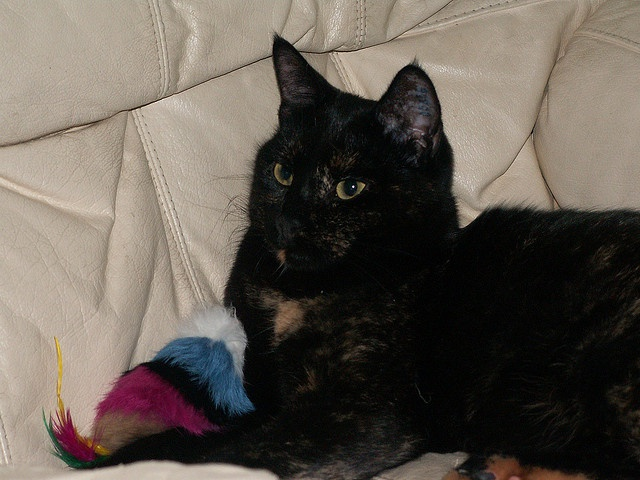Describe the objects in this image and their specific colors. I can see couch in darkgray, gray, and tan tones and cat in darkgray, black, gray, and maroon tones in this image. 